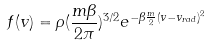<formula> <loc_0><loc_0><loc_500><loc_500>f ( v ) = \rho ( \frac { m \beta } { 2 \pi } ) ^ { 3 / 2 } e ^ { - \beta \frac { m } { 2 } ( v - v _ { r a d } ) ^ { 2 } }</formula> 